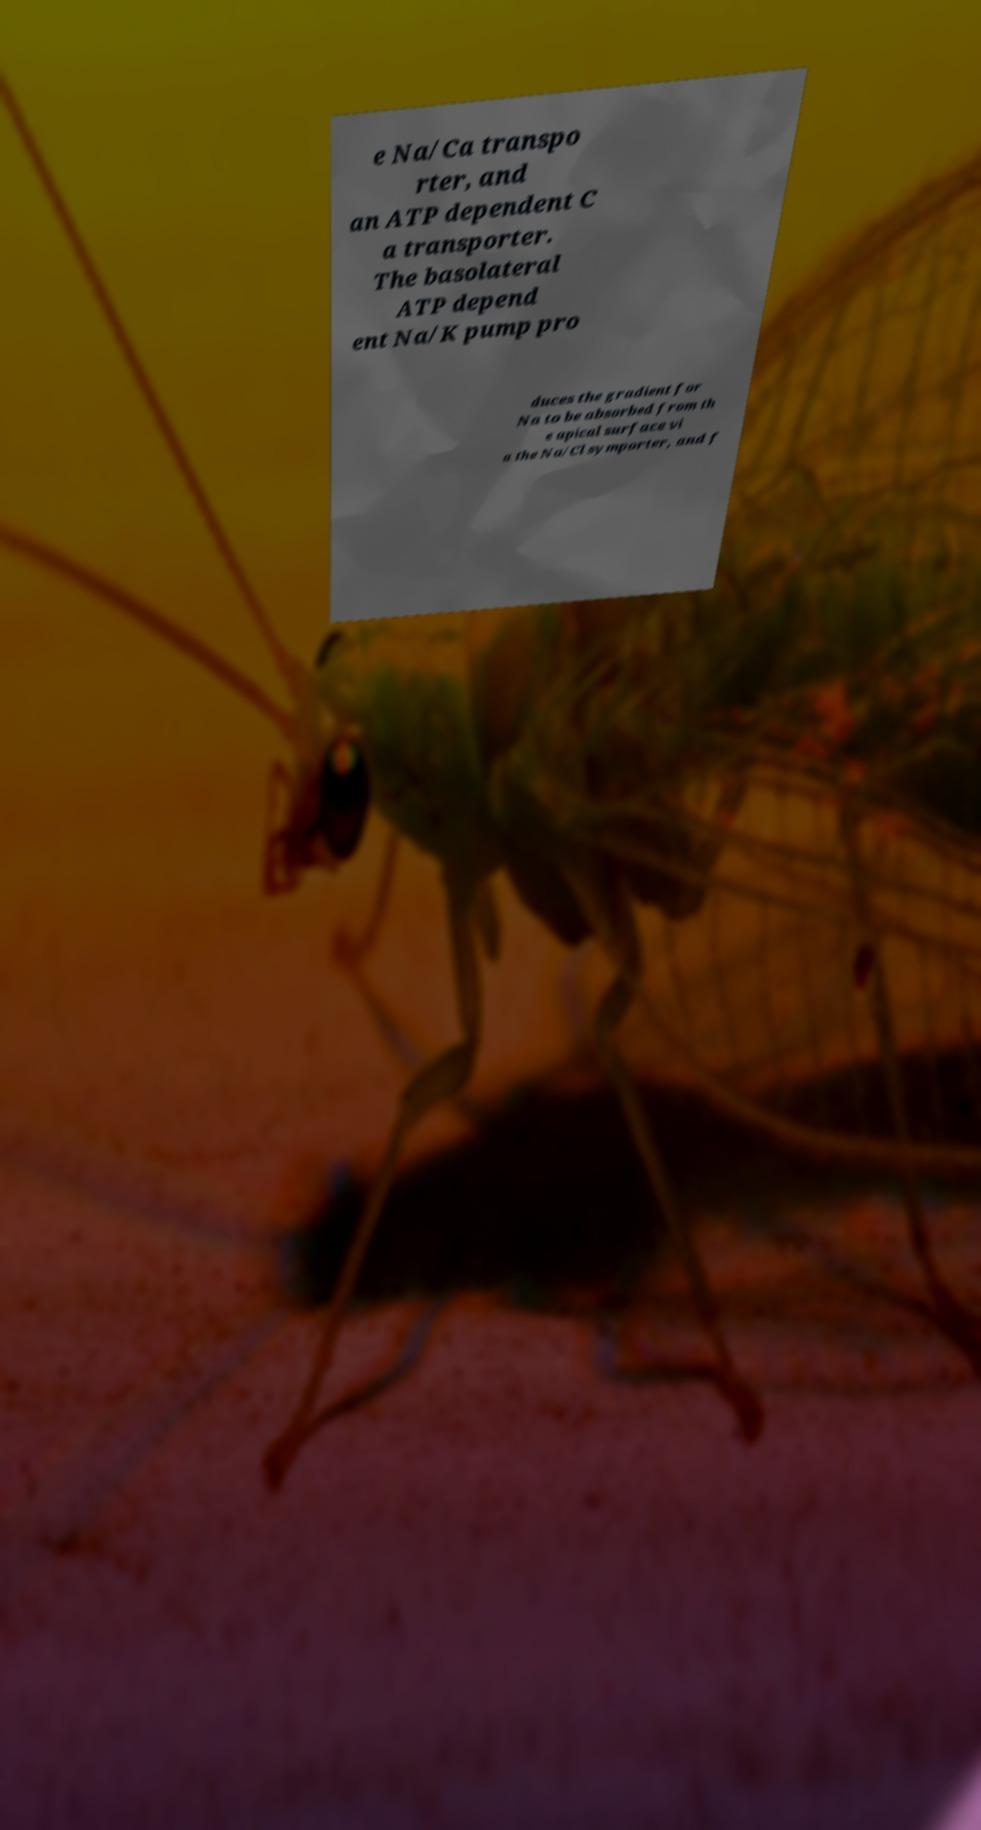Please identify and transcribe the text found in this image. e Na/Ca transpo rter, and an ATP dependent C a transporter. The basolateral ATP depend ent Na/K pump pro duces the gradient for Na to be absorbed from th e apical surface vi a the Na/Cl symporter, and f 